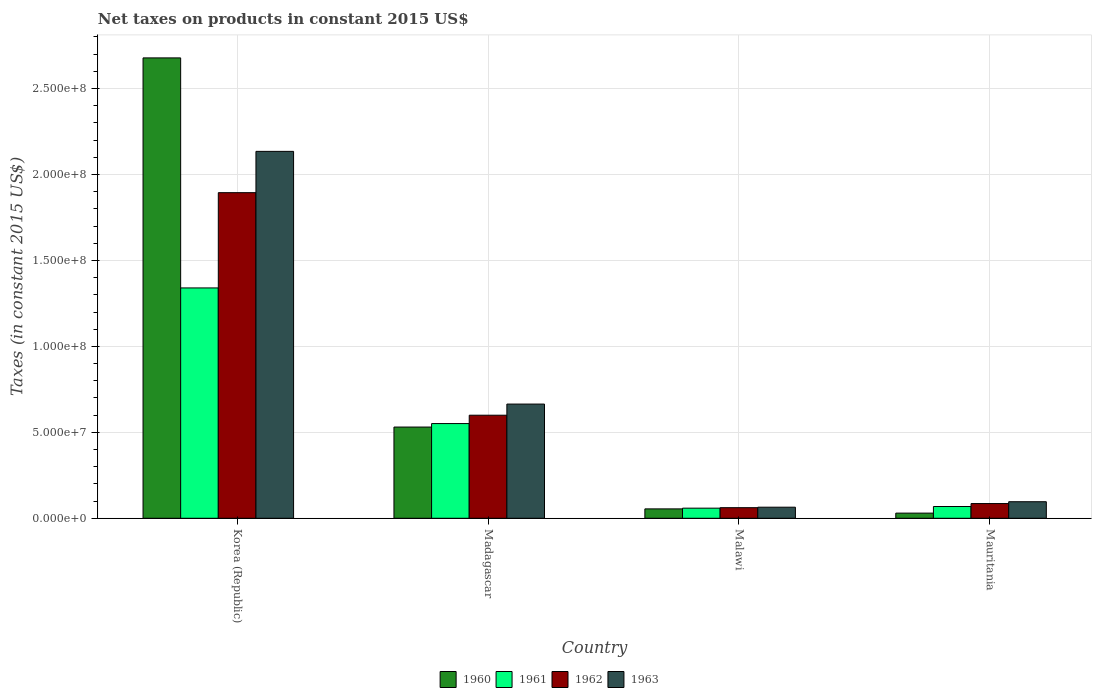How many different coloured bars are there?
Your answer should be compact. 4. How many groups of bars are there?
Your answer should be very brief. 4. Are the number of bars per tick equal to the number of legend labels?
Provide a succinct answer. Yes. Are the number of bars on each tick of the X-axis equal?
Ensure brevity in your answer.  Yes. How many bars are there on the 3rd tick from the right?
Your response must be concise. 4. What is the label of the 2nd group of bars from the left?
Provide a short and direct response. Madagascar. In how many cases, is the number of bars for a given country not equal to the number of legend labels?
Provide a succinct answer. 0. What is the net taxes on products in 1962 in Madagascar?
Your answer should be compact. 6.00e+07. Across all countries, what is the maximum net taxes on products in 1962?
Provide a short and direct response. 1.89e+08. Across all countries, what is the minimum net taxes on products in 1960?
Give a very brief answer. 3.00e+06. In which country was the net taxes on products in 1961 maximum?
Offer a terse response. Korea (Republic). In which country was the net taxes on products in 1960 minimum?
Provide a short and direct response. Mauritania. What is the total net taxes on products in 1961 in the graph?
Your answer should be very brief. 2.02e+08. What is the difference between the net taxes on products in 1962 in Madagascar and that in Mauritania?
Your answer should be very brief. 5.14e+07. What is the difference between the net taxes on products in 1961 in Malawi and the net taxes on products in 1963 in Korea (Republic)?
Ensure brevity in your answer.  -2.08e+08. What is the average net taxes on products in 1963 per country?
Your answer should be compact. 7.40e+07. What is the difference between the net taxes on products of/in 1961 and net taxes on products of/in 1960 in Malawi?
Give a very brief answer. 4.20e+05. What is the ratio of the net taxes on products in 1960 in Madagascar to that in Malawi?
Offer a terse response. 9.72. Is the net taxes on products in 1960 in Madagascar less than that in Malawi?
Your response must be concise. No. What is the difference between the highest and the second highest net taxes on products in 1960?
Provide a succinct answer. 4.76e+07. What is the difference between the highest and the lowest net taxes on products in 1960?
Make the answer very short. 2.65e+08. Is the sum of the net taxes on products in 1963 in Madagascar and Malawi greater than the maximum net taxes on products in 1962 across all countries?
Your answer should be very brief. No. Is it the case that in every country, the sum of the net taxes on products in 1961 and net taxes on products in 1960 is greater than the sum of net taxes on products in 1962 and net taxes on products in 1963?
Your answer should be very brief. No. What does the 1st bar from the right in Mauritania represents?
Your response must be concise. 1963. Is it the case that in every country, the sum of the net taxes on products in 1960 and net taxes on products in 1963 is greater than the net taxes on products in 1961?
Ensure brevity in your answer.  Yes. Are all the bars in the graph horizontal?
Your answer should be very brief. No. How many countries are there in the graph?
Make the answer very short. 4. Does the graph contain any zero values?
Provide a succinct answer. No. Does the graph contain grids?
Provide a succinct answer. Yes. Where does the legend appear in the graph?
Provide a succinct answer. Bottom center. How many legend labels are there?
Offer a very short reply. 4. How are the legend labels stacked?
Offer a terse response. Horizontal. What is the title of the graph?
Your response must be concise. Net taxes on products in constant 2015 US$. Does "2001" appear as one of the legend labels in the graph?
Your answer should be compact. No. What is the label or title of the X-axis?
Your answer should be compact. Country. What is the label or title of the Y-axis?
Offer a very short reply. Taxes (in constant 2015 US$). What is the Taxes (in constant 2015 US$) in 1960 in Korea (Republic)?
Provide a short and direct response. 2.68e+08. What is the Taxes (in constant 2015 US$) of 1961 in Korea (Republic)?
Make the answer very short. 1.34e+08. What is the Taxes (in constant 2015 US$) of 1962 in Korea (Republic)?
Offer a terse response. 1.89e+08. What is the Taxes (in constant 2015 US$) in 1963 in Korea (Republic)?
Your answer should be compact. 2.13e+08. What is the Taxes (in constant 2015 US$) in 1960 in Madagascar?
Offer a very short reply. 5.31e+07. What is the Taxes (in constant 2015 US$) in 1961 in Madagascar?
Provide a short and direct response. 5.51e+07. What is the Taxes (in constant 2015 US$) in 1962 in Madagascar?
Your answer should be compact. 6.00e+07. What is the Taxes (in constant 2015 US$) in 1963 in Madagascar?
Provide a succinct answer. 6.64e+07. What is the Taxes (in constant 2015 US$) of 1960 in Malawi?
Provide a short and direct response. 5.46e+06. What is the Taxes (in constant 2015 US$) of 1961 in Malawi?
Keep it short and to the point. 5.88e+06. What is the Taxes (in constant 2015 US$) of 1962 in Malawi?
Your answer should be compact. 6.16e+06. What is the Taxes (in constant 2015 US$) of 1963 in Malawi?
Make the answer very short. 6.44e+06. What is the Taxes (in constant 2015 US$) in 1960 in Mauritania?
Your answer should be very brief. 3.00e+06. What is the Taxes (in constant 2015 US$) of 1961 in Mauritania?
Provide a succinct answer. 6.85e+06. What is the Taxes (in constant 2015 US$) in 1962 in Mauritania?
Keep it short and to the point. 8.56e+06. What is the Taxes (in constant 2015 US$) of 1963 in Mauritania?
Provide a short and direct response. 9.63e+06. Across all countries, what is the maximum Taxes (in constant 2015 US$) in 1960?
Offer a terse response. 2.68e+08. Across all countries, what is the maximum Taxes (in constant 2015 US$) of 1961?
Provide a succinct answer. 1.34e+08. Across all countries, what is the maximum Taxes (in constant 2015 US$) in 1962?
Give a very brief answer. 1.89e+08. Across all countries, what is the maximum Taxes (in constant 2015 US$) in 1963?
Your answer should be very brief. 2.13e+08. Across all countries, what is the minimum Taxes (in constant 2015 US$) of 1960?
Your answer should be compact. 3.00e+06. Across all countries, what is the minimum Taxes (in constant 2015 US$) of 1961?
Ensure brevity in your answer.  5.88e+06. Across all countries, what is the minimum Taxes (in constant 2015 US$) in 1962?
Offer a very short reply. 6.16e+06. Across all countries, what is the minimum Taxes (in constant 2015 US$) in 1963?
Keep it short and to the point. 6.44e+06. What is the total Taxes (in constant 2015 US$) in 1960 in the graph?
Provide a succinct answer. 3.29e+08. What is the total Taxes (in constant 2015 US$) of 1961 in the graph?
Your response must be concise. 2.02e+08. What is the total Taxes (in constant 2015 US$) of 1962 in the graph?
Give a very brief answer. 2.64e+08. What is the total Taxes (in constant 2015 US$) in 1963 in the graph?
Your answer should be very brief. 2.96e+08. What is the difference between the Taxes (in constant 2015 US$) of 1960 in Korea (Republic) and that in Madagascar?
Make the answer very short. 2.15e+08. What is the difference between the Taxes (in constant 2015 US$) in 1961 in Korea (Republic) and that in Madagascar?
Offer a terse response. 7.89e+07. What is the difference between the Taxes (in constant 2015 US$) in 1962 in Korea (Republic) and that in Madagascar?
Make the answer very short. 1.29e+08. What is the difference between the Taxes (in constant 2015 US$) of 1963 in Korea (Republic) and that in Madagascar?
Provide a succinct answer. 1.47e+08. What is the difference between the Taxes (in constant 2015 US$) of 1960 in Korea (Republic) and that in Malawi?
Make the answer very short. 2.62e+08. What is the difference between the Taxes (in constant 2015 US$) in 1961 in Korea (Republic) and that in Malawi?
Your answer should be compact. 1.28e+08. What is the difference between the Taxes (in constant 2015 US$) in 1962 in Korea (Republic) and that in Malawi?
Offer a terse response. 1.83e+08. What is the difference between the Taxes (in constant 2015 US$) of 1963 in Korea (Republic) and that in Malawi?
Your response must be concise. 2.07e+08. What is the difference between the Taxes (in constant 2015 US$) in 1960 in Korea (Republic) and that in Mauritania?
Keep it short and to the point. 2.65e+08. What is the difference between the Taxes (in constant 2015 US$) of 1961 in Korea (Republic) and that in Mauritania?
Offer a terse response. 1.27e+08. What is the difference between the Taxes (in constant 2015 US$) of 1962 in Korea (Republic) and that in Mauritania?
Offer a very short reply. 1.81e+08. What is the difference between the Taxes (in constant 2015 US$) of 1963 in Korea (Republic) and that in Mauritania?
Offer a terse response. 2.04e+08. What is the difference between the Taxes (in constant 2015 US$) of 1960 in Madagascar and that in Malawi?
Ensure brevity in your answer.  4.76e+07. What is the difference between the Taxes (in constant 2015 US$) in 1961 in Madagascar and that in Malawi?
Provide a succinct answer. 4.92e+07. What is the difference between the Taxes (in constant 2015 US$) in 1962 in Madagascar and that in Malawi?
Make the answer very short. 5.38e+07. What is the difference between the Taxes (in constant 2015 US$) of 1963 in Madagascar and that in Malawi?
Your answer should be compact. 6.00e+07. What is the difference between the Taxes (in constant 2015 US$) of 1960 in Madagascar and that in Mauritania?
Ensure brevity in your answer.  5.01e+07. What is the difference between the Taxes (in constant 2015 US$) of 1961 in Madagascar and that in Mauritania?
Provide a succinct answer. 4.82e+07. What is the difference between the Taxes (in constant 2015 US$) in 1962 in Madagascar and that in Mauritania?
Your answer should be very brief. 5.14e+07. What is the difference between the Taxes (in constant 2015 US$) in 1963 in Madagascar and that in Mauritania?
Provide a short and direct response. 5.68e+07. What is the difference between the Taxes (in constant 2015 US$) of 1960 in Malawi and that in Mauritania?
Offer a very short reply. 2.46e+06. What is the difference between the Taxes (in constant 2015 US$) in 1961 in Malawi and that in Mauritania?
Your answer should be very brief. -9.67e+05. What is the difference between the Taxes (in constant 2015 US$) of 1962 in Malawi and that in Mauritania?
Make the answer very short. -2.40e+06. What is the difference between the Taxes (in constant 2015 US$) in 1963 in Malawi and that in Mauritania?
Ensure brevity in your answer.  -3.19e+06. What is the difference between the Taxes (in constant 2015 US$) of 1960 in Korea (Republic) and the Taxes (in constant 2015 US$) of 1961 in Madagascar?
Offer a very short reply. 2.13e+08. What is the difference between the Taxes (in constant 2015 US$) of 1960 in Korea (Republic) and the Taxes (in constant 2015 US$) of 1962 in Madagascar?
Your response must be concise. 2.08e+08. What is the difference between the Taxes (in constant 2015 US$) in 1960 in Korea (Republic) and the Taxes (in constant 2015 US$) in 1963 in Madagascar?
Provide a short and direct response. 2.01e+08. What is the difference between the Taxes (in constant 2015 US$) of 1961 in Korea (Republic) and the Taxes (in constant 2015 US$) of 1962 in Madagascar?
Provide a succinct answer. 7.41e+07. What is the difference between the Taxes (in constant 2015 US$) in 1961 in Korea (Republic) and the Taxes (in constant 2015 US$) in 1963 in Madagascar?
Give a very brief answer. 6.76e+07. What is the difference between the Taxes (in constant 2015 US$) of 1962 in Korea (Republic) and the Taxes (in constant 2015 US$) of 1963 in Madagascar?
Offer a terse response. 1.23e+08. What is the difference between the Taxes (in constant 2015 US$) in 1960 in Korea (Republic) and the Taxes (in constant 2015 US$) in 1961 in Malawi?
Keep it short and to the point. 2.62e+08. What is the difference between the Taxes (in constant 2015 US$) in 1960 in Korea (Republic) and the Taxes (in constant 2015 US$) in 1962 in Malawi?
Give a very brief answer. 2.62e+08. What is the difference between the Taxes (in constant 2015 US$) of 1960 in Korea (Republic) and the Taxes (in constant 2015 US$) of 1963 in Malawi?
Offer a terse response. 2.61e+08. What is the difference between the Taxes (in constant 2015 US$) in 1961 in Korea (Republic) and the Taxes (in constant 2015 US$) in 1962 in Malawi?
Your response must be concise. 1.28e+08. What is the difference between the Taxes (in constant 2015 US$) in 1961 in Korea (Republic) and the Taxes (in constant 2015 US$) in 1963 in Malawi?
Make the answer very short. 1.28e+08. What is the difference between the Taxes (in constant 2015 US$) of 1962 in Korea (Republic) and the Taxes (in constant 2015 US$) of 1963 in Malawi?
Offer a terse response. 1.83e+08. What is the difference between the Taxes (in constant 2015 US$) in 1960 in Korea (Republic) and the Taxes (in constant 2015 US$) in 1961 in Mauritania?
Your response must be concise. 2.61e+08. What is the difference between the Taxes (in constant 2015 US$) in 1960 in Korea (Republic) and the Taxes (in constant 2015 US$) in 1962 in Mauritania?
Keep it short and to the point. 2.59e+08. What is the difference between the Taxes (in constant 2015 US$) in 1960 in Korea (Republic) and the Taxes (in constant 2015 US$) in 1963 in Mauritania?
Make the answer very short. 2.58e+08. What is the difference between the Taxes (in constant 2015 US$) in 1961 in Korea (Republic) and the Taxes (in constant 2015 US$) in 1962 in Mauritania?
Give a very brief answer. 1.25e+08. What is the difference between the Taxes (in constant 2015 US$) of 1961 in Korea (Republic) and the Taxes (in constant 2015 US$) of 1963 in Mauritania?
Ensure brevity in your answer.  1.24e+08. What is the difference between the Taxes (in constant 2015 US$) in 1962 in Korea (Republic) and the Taxes (in constant 2015 US$) in 1963 in Mauritania?
Provide a succinct answer. 1.80e+08. What is the difference between the Taxes (in constant 2015 US$) in 1960 in Madagascar and the Taxes (in constant 2015 US$) in 1961 in Malawi?
Provide a succinct answer. 4.72e+07. What is the difference between the Taxes (in constant 2015 US$) in 1960 in Madagascar and the Taxes (in constant 2015 US$) in 1962 in Malawi?
Offer a terse response. 4.69e+07. What is the difference between the Taxes (in constant 2015 US$) of 1960 in Madagascar and the Taxes (in constant 2015 US$) of 1963 in Malawi?
Give a very brief answer. 4.66e+07. What is the difference between the Taxes (in constant 2015 US$) in 1961 in Madagascar and the Taxes (in constant 2015 US$) in 1962 in Malawi?
Your answer should be very brief. 4.89e+07. What is the difference between the Taxes (in constant 2015 US$) in 1961 in Madagascar and the Taxes (in constant 2015 US$) in 1963 in Malawi?
Give a very brief answer. 4.87e+07. What is the difference between the Taxes (in constant 2015 US$) of 1962 in Madagascar and the Taxes (in constant 2015 US$) of 1963 in Malawi?
Your answer should be compact. 5.35e+07. What is the difference between the Taxes (in constant 2015 US$) of 1960 in Madagascar and the Taxes (in constant 2015 US$) of 1961 in Mauritania?
Provide a succinct answer. 4.62e+07. What is the difference between the Taxes (in constant 2015 US$) in 1960 in Madagascar and the Taxes (in constant 2015 US$) in 1962 in Mauritania?
Make the answer very short. 4.45e+07. What is the difference between the Taxes (in constant 2015 US$) in 1960 in Madagascar and the Taxes (in constant 2015 US$) in 1963 in Mauritania?
Offer a terse response. 4.34e+07. What is the difference between the Taxes (in constant 2015 US$) in 1961 in Madagascar and the Taxes (in constant 2015 US$) in 1962 in Mauritania?
Offer a very short reply. 4.65e+07. What is the difference between the Taxes (in constant 2015 US$) of 1961 in Madagascar and the Taxes (in constant 2015 US$) of 1963 in Mauritania?
Offer a very short reply. 4.55e+07. What is the difference between the Taxes (in constant 2015 US$) in 1962 in Madagascar and the Taxes (in constant 2015 US$) in 1963 in Mauritania?
Your response must be concise. 5.03e+07. What is the difference between the Taxes (in constant 2015 US$) of 1960 in Malawi and the Taxes (in constant 2015 US$) of 1961 in Mauritania?
Make the answer very short. -1.39e+06. What is the difference between the Taxes (in constant 2015 US$) of 1960 in Malawi and the Taxes (in constant 2015 US$) of 1962 in Mauritania?
Give a very brief answer. -3.10e+06. What is the difference between the Taxes (in constant 2015 US$) of 1960 in Malawi and the Taxes (in constant 2015 US$) of 1963 in Mauritania?
Keep it short and to the point. -4.17e+06. What is the difference between the Taxes (in constant 2015 US$) in 1961 in Malawi and the Taxes (in constant 2015 US$) in 1962 in Mauritania?
Your answer should be compact. -2.68e+06. What is the difference between the Taxes (in constant 2015 US$) in 1961 in Malawi and the Taxes (in constant 2015 US$) in 1963 in Mauritania?
Give a very brief answer. -3.75e+06. What is the difference between the Taxes (in constant 2015 US$) of 1962 in Malawi and the Taxes (in constant 2015 US$) of 1963 in Mauritania?
Ensure brevity in your answer.  -3.47e+06. What is the average Taxes (in constant 2015 US$) in 1960 per country?
Make the answer very short. 8.23e+07. What is the average Taxes (in constant 2015 US$) of 1961 per country?
Provide a short and direct response. 5.05e+07. What is the average Taxes (in constant 2015 US$) in 1962 per country?
Make the answer very short. 6.60e+07. What is the average Taxes (in constant 2015 US$) of 1963 per country?
Give a very brief answer. 7.40e+07. What is the difference between the Taxes (in constant 2015 US$) in 1960 and Taxes (in constant 2015 US$) in 1961 in Korea (Republic)?
Your answer should be compact. 1.34e+08. What is the difference between the Taxes (in constant 2015 US$) of 1960 and Taxes (in constant 2015 US$) of 1962 in Korea (Republic)?
Provide a succinct answer. 7.84e+07. What is the difference between the Taxes (in constant 2015 US$) in 1960 and Taxes (in constant 2015 US$) in 1963 in Korea (Republic)?
Make the answer very short. 5.44e+07. What is the difference between the Taxes (in constant 2015 US$) of 1961 and Taxes (in constant 2015 US$) of 1962 in Korea (Republic)?
Make the answer very short. -5.54e+07. What is the difference between the Taxes (in constant 2015 US$) in 1961 and Taxes (in constant 2015 US$) in 1963 in Korea (Republic)?
Provide a short and direct response. -7.94e+07. What is the difference between the Taxes (in constant 2015 US$) in 1962 and Taxes (in constant 2015 US$) in 1963 in Korea (Republic)?
Make the answer very short. -2.40e+07. What is the difference between the Taxes (in constant 2015 US$) in 1960 and Taxes (in constant 2015 US$) in 1961 in Madagascar?
Make the answer very short. -2.03e+06. What is the difference between the Taxes (in constant 2015 US$) in 1960 and Taxes (in constant 2015 US$) in 1962 in Madagascar?
Ensure brevity in your answer.  -6.89e+06. What is the difference between the Taxes (in constant 2015 US$) of 1960 and Taxes (in constant 2015 US$) of 1963 in Madagascar?
Keep it short and to the point. -1.34e+07. What is the difference between the Taxes (in constant 2015 US$) in 1961 and Taxes (in constant 2015 US$) in 1962 in Madagascar?
Keep it short and to the point. -4.86e+06. What is the difference between the Taxes (in constant 2015 US$) in 1961 and Taxes (in constant 2015 US$) in 1963 in Madagascar?
Your answer should be very brief. -1.13e+07. What is the difference between the Taxes (in constant 2015 US$) of 1962 and Taxes (in constant 2015 US$) of 1963 in Madagascar?
Your answer should be very brief. -6.48e+06. What is the difference between the Taxes (in constant 2015 US$) in 1960 and Taxes (in constant 2015 US$) in 1961 in Malawi?
Offer a terse response. -4.20e+05. What is the difference between the Taxes (in constant 2015 US$) in 1960 and Taxes (in constant 2015 US$) in 1962 in Malawi?
Offer a very short reply. -7.00e+05. What is the difference between the Taxes (in constant 2015 US$) in 1960 and Taxes (in constant 2015 US$) in 1963 in Malawi?
Offer a terse response. -9.80e+05. What is the difference between the Taxes (in constant 2015 US$) of 1961 and Taxes (in constant 2015 US$) of 1962 in Malawi?
Your answer should be very brief. -2.80e+05. What is the difference between the Taxes (in constant 2015 US$) of 1961 and Taxes (in constant 2015 US$) of 1963 in Malawi?
Your answer should be compact. -5.60e+05. What is the difference between the Taxes (in constant 2015 US$) in 1962 and Taxes (in constant 2015 US$) in 1963 in Malawi?
Ensure brevity in your answer.  -2.80e+05. What is the difference between the Taxes (in constant 2015 US$) in 1960 and Taxes (in constant 2015 US$) in 1961 in Mauritania?
Provide a short and direct response. -3.85e+06. What is the difference between the Taxes (in constant 2015 US$) in 1960 and Taxes (in constant 2015 US$) in 1962 in Mauritania?
Give a very brief answer. -5.56e+06. What is the difference between the Taxes (in constant 2015 US$) in 1960 and Taxes (in constant 2015 US$) in 1963 in Mauritania?
Provide a succinct answer. -6.63e+06. What is the difference between the Taxes (in constant 2015 US$) of 1961 and Taxes (in constant 2015 US$) of 1962 in Mauritania?
Provide a succinct answer. -1.71e+06. What is the difference between the Taxes (in constant 2015 US$) of 1961 and Taxes (in constant 2015 US$) of 1963 in Mauritania?
Provide a succinct answer. -2.78e+06. What is the difference between the Taxes (in constant 2015 US$) of 1962 and Taxes (in constant 2015 US$) of 1963 in Mauritania?
Make the answer very short. -1.07e+06. What is the ratio of the Taxes (in constant 2015 US$) in 1960 in Korea (Republic) to that in Madagascar?
Offer a very short reply. 5.05. What is the ratio of the Taxes (in constant 2015 US$) of 1961 in Korea (Republic) to that in Madagascar?
Ensure brevity in your answer.  2.43. What is the ratio of the Taxes (in constant 2015 US$) of 1962 in Korea (Republic) to that in Madagascar?
Provide a short and direct response. 3.16. What is the ratio of the Taxes (in constant 2015 US$) in 1963 in Korea (Republic) to that in Madagascar?
Provide a succinct answer. 3.21. What is the ratio of the Taxes (in constant 2015 US$) of 1960 in Korea (Republic) to that in Malawi?
Give a very brief answer. 49.05. What is the ratio of the Taxes (in constant 2015 US$) in 1961 in Korea (Republic) to that in Malawi?
Your answer should be very brief. 22.79. What is the ratio of the Taxes (in constant 2015 US$) in 1962 in Korea (Republic) to that in Malawi?
Provide a succinct answer. 30.75. What is the ratio of the Taxes (in constant 2015 US$) in 1963 in Korea (Republic) to that in Malawi?
Your answer should be very brief. 33.15. What is the ratio of the Taxes (in constant 2015 US$) in 1960 in Korea (Republic) to that in Mauritania?
Keep it short and to the point. 89.41. What is the ratio of the Taxes (in constant 2015 US$) of 1961 in Korea (Republic) to that in Mauritania?
Your answer should be very brief. 19.57. What is the ratio of the Taxes (in constant 2015 US$) in 1962 in Korea (Republic) to that in Mauritania?
Offer a very short reply. 22.13. What is the ratio of the Taxes (in constant 2015 US$) of 1963 in Korea (Republic) to that in Mauritania?
Keep it short and to the point. 22.17. What is the ratio of the Taxes (in constant 2015 US$) in 1960 in Madagascar to that in Malawi?
Provide a short and direct response. 9.72. What is the ratio of the Taxes (in constant 2015 US$) in 1961 in Madagascar to that in Malawi?
Give a very brief answer. 9.37. What is the ratio of the Taxes (in constant 2015 US$) in 1962 in Madagascar to that in Malawi?
Provide a short and direct response. 9.73. What is the ratio of the Taxes (in constant 2015 US$) in 1963 in Madagascar to that in Malawi?
Your answer should be compact. 10.32. What is the ratio of the Taxes (in constant 2015 US$) in 1960 in Madagascar to that in Mauritania?
Make the answer very short. 17.72. What is the ratio of the Taxes (in constant 2015 US$) of 1961 in Madagascar to that in Mauritania?
Provide a succinct answer. 8.05. What is the ratio of the Taxes (in constant 2015 US$) of 1962 in Madagascar to that in Mauritania?
Provide a succinct answer. 7. What is the ratio of the Taxes (in constant 2015 US$) in 1963 in Madagascar to that in Mauritania?
Provide a short and direct response. 6.9. What is the ratio of the Taxes (in constant 2015 US$) of 1960 in Malawi to that in Mauritania?
Offer a terse response. 1.82. What is the ratio of the Taxes (in constant 2015 US$) of 1961 in Malawi to that in Mauritania?
Provide a succinct answer. 0.86. What is the ratio of the Taxes (in constant 2015 US$) in 1962 in Malawi to that in Mauritania?
Your answer should be compact. 0.72. What is the ratio of the Taxes (in constant 2015 US$) of 1963 in Malawi to that in Mauritania?
Offer a terse response. 0.67. What is the difference between the highest and the second highest Taxes (in constant 2015 US$) of 1960?
Your answer should be compact. 2.15e+08. What is the difference between the highest and the second highest Taxes (in constant 2015 US$) in 1961?
Your response must be concise. 7.89e+07. What is the difference between the highest and the second highest Taxes (in constant 2015 US$) of 1962?
Provide a short and direct response. 1.29e+08. What is the difference between the highest and the second highest Taxes (in constant 2015 US$) of 1963?
Your answer should be very brief. 1.47e+08. What is the difference between the highest and the lowest Taxes (in constant 2015 US$) of 1960?
Offer a very short reply. 2.65e+08. What is the difference between the highest and the lowest Taxes (in constant 2015 US$) in 1961?
Offer a terse response. 1.28e+08. What is the difference between the highest and the lowest Taxes (in constant 2015 US$) in 1962?
Provide a succinct answer. 1.83e+08. What is the difference between the highest and the lowest Taxes (in constant 2015 US$) of 1963?
Offer a very short reply. 2.07e+08. 